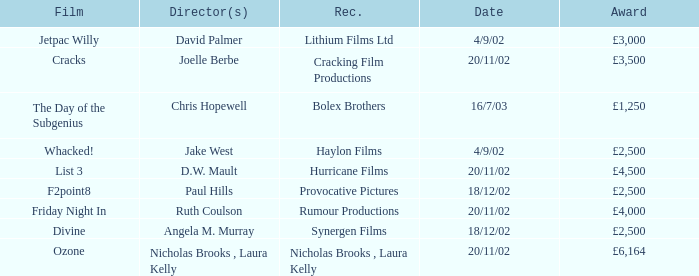Who won an award of £3,000 on 4/9/02? Lithium Films Ltd. 